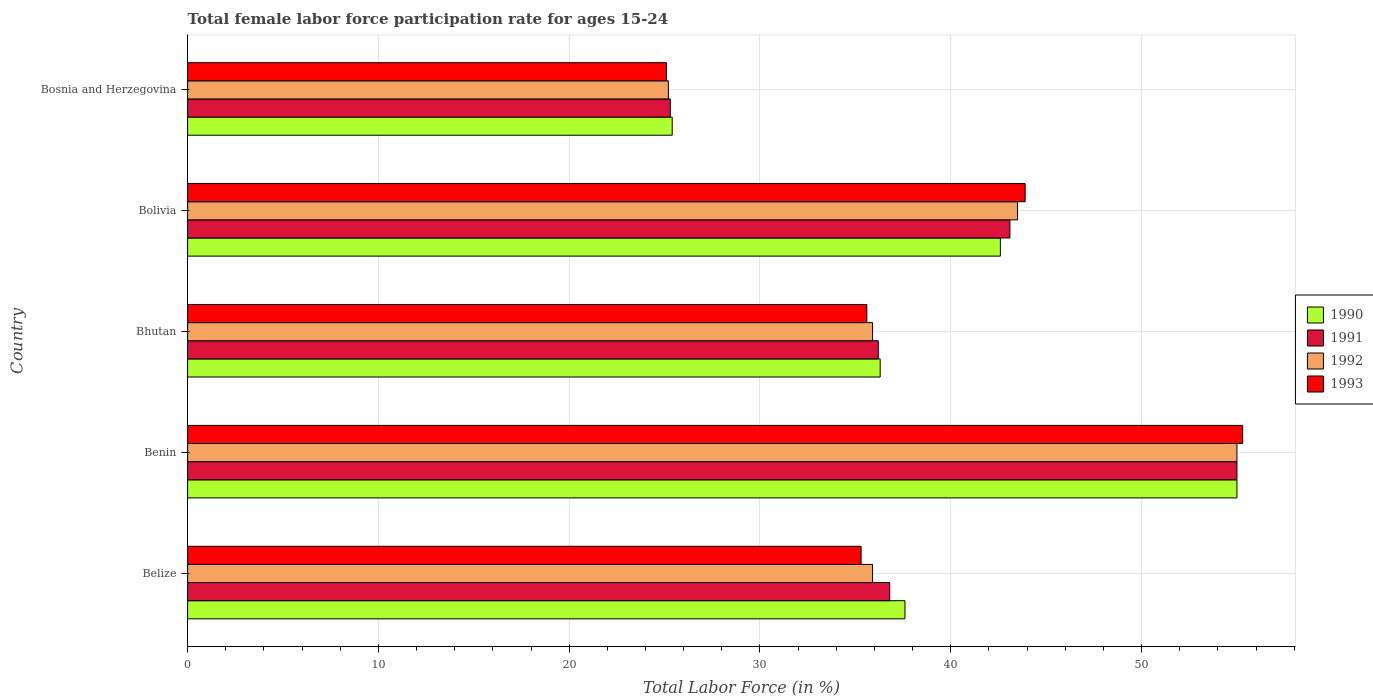How many different coloured bars are there?
Provide a short and direct response. 4. How many groups of bars are there?
Give a very brief answer. 5. Are the number of bars on each tick of the Y-axis equal?
Make the answer very short. Yes. How many bars are there on the 5th tick from the bottom?
Give a very brief answer. 4. What is the label of the 5th group of bars from the top?
Give a very brief answer. Belize. What is the female labor force participation rate in 1991 in Bosnia and Herzegovina?
Provide a short and direct response. 25.3. Across all countries, what is the minimum female labor force participation rate in 1993?
Provide a short and direct response. 25.1. In which country was the female labor force participation rate in 1992 maximum?
Ensure brevity in your answer.  Benin. In which country was the female labor force participation rate in 1992 minimum?
Provide a succinct answer. Bosnia and Herzegovina. What is the total female labor force participation rate in 1993 in the graph?
Keep it short and to the point. 195.2. What is the difference between the female labor force participation rate in 1993 in Bolivia and the female labor force participation rate in 1990 in Benin?
Ensure brevity in your answer.  -11.1. What is the average female labor force participation rate in 1992 per country?
Your answer should be compact. 39.1. What is the difference between the female labor force participation rate in 1990 and female labor force participation rate in 1991 in Belize?
Offer a very short reply. 0.8. In how many countries, is the female labor force participation rate in 1991 greater than 4 %?
Give a very brief answer. 5. What is the ratio of the female labor force participation rate in 1990 in Bhutan to that in Bosnia and Herzegovina?
Ensure brevity in your answer.  1.43. Is the female labor force participation rate in 1991 in Bhutan less than that in Bolivia?
Your answer should be compact. Yes. What is the difference between the highest and the second highest female labor force participation rate in 1991?
Make the answer very short. 11.9. What is the difference between the highest and the lowest female labor force participation rate in 1991?
Your answer should be compact. 29.7. Is it the case that in every country, the sum of the female labor force participation rate in 1991 and female labor force participation rate in 1992 is greater than the sum of female labor force participation rate in 1993 and female labor force participation rate in 1990?
Your answer should be very brief. No. What does the 2nd bar from the top in Belize represents?
Provide a succinct answer. 1992. What does the 2nd bar from the bottom in Benin represents?
Make the answer very short. 1991. Is it the case that in every country, the sum of the female labor force participation rate in 1992 and female labor force participation rate in 1990 is greater than the female labor force participation rate in 1991?
Your answer should be very brief. Yes. How many legend labels are there?
Your answer should be very brief. 4. How are the legend labels stacked?
Your answer should be very brief. Vertical. What is the title of the graph?
Keep it short and to the point. Total female labor force participation rate for ages 15-24. Does "2014" appear as one of the legend labels in the graph?
Provide a succinct answer. No. What is the label or title of the X-axis?
Give a very brief answer. Total Labor Force (in %). What is the label or title of the Y-axis?
Ensure brevity in your answer.  Country. What is the Total Labor Force (in %) in 1990 in Belize?
Give a very brief answer. 37.6. What is the Total Labor Force (in %) of 1991 in Belize?
Your answer should be very brief. 36.8. What is the Total Labor Force (in %) of 1992 in Belize?
Keep it short and to the point. 35.9. What is the Total Labor Force (in %) of 1993 in Belize?
Your response must be concise. 35.3. What is the Total Labor Force (in %) in 1990 in Benin?
Keep it short and to the point. 55. What is the Total Labor Force (in %) of 1993 in Benin?
Provide a short and direct response. 55.3. What is the Total Labor Force (in %) of 1990 in Bhutan?
Your answer should be compact. 36.3. What is the Total Labor Force (in %) of 1991 in Bhutan?
Offer a very short reply. 36.2. What is the Total Labor Force (in %) of 1992 in Bhutan?
Ensure brevity in your answer.  35.9. What is the Total Labor Force (in %) in 1993 in Bhutan?
Provide a short and direct response. 35.6. What is the Total Labor Force (in %) of 1990 in Bolivia?
Give a very brief answer. 42.6. What is the Total Labor Force (in %) of 1991 in Bolivia?
Offer a very short reply. 43.1. What is the Total Labor Force (in %) in 1992 in Bolivia?
Offer a very short reply. 43.5. What is the Total Labor Force (in %) of 1993 in Bolivia?
Your response must be concise. 43.9. What is the Total Labor Force (in %) in 1990 in Bosnia and Herzegovina?
Keep it short and to the point. 25.4. What is the Total Labor Force (in %) in 1991 in Bosnia and Herzegovina?
Offer a terse response. 25.3. What is the Total Labor Force (in %) of 1992 in Bosnia and Herzegovina?
Give a very brief answer. 25.2. What is the Total Labor Force (in %) in 1993 in Bosnia and Herzegovina?
Offer a terse response. 25.1. Across all countries, what is the maximum Total Labor Force (in %) of 1990?
Your answer should be compact. 55. Across all countries, what is the maximum Total Labor Force (in %) in 1992?
Offer a very short reply. 55. Across all countries, what is the maximum Total Labor Force (in %) of 1993?
Keep it short and to the point. 55.3. Across all countries, what is the minimum Total Labor Force (in %) of 1990?
Offer a terse response. 25.4. Across all countries, what is the minimum Total Labor Force (in %) in 1991?
Offer a very short reply. 25.3. Across all countries, what is the minimum Total Labor Force (in %) of 1992?
Provide a succinct answer. 25.2. Across all countries, what is the minimum Total Labor Force (in %) in 1993?
Your response must be concise. 25.1. What is the total Total Labor Force (in %) in 1990 in the graph?
Keep it short and to the point. 196.9. What is the total Total Labor Force (in %) of 1991 in the graph?
Ensure brevity in your answer.  196.4. What is the total Total Labor Force (in %) of 1992 in the graph?
Offer a very short reply. 195.5. What is the total Total Labor Force (in %) in 1993 in the graph?
Your answer should be compact. 195.2. What is the difference between the Total Labor Force (in %) of 1990 in Belize and that in Benin?
Offer a terse response. -17.4. What is the difference between the Total Labor Force (in %) of 1991 in Belize and that in Benin?
Ensure brevity in your answer.  -18.2. What is the difference between the Total Labor Force (in %) of 1992 in Belize and that in Benin?
Your answer should be very brief. -19.1. What is the difference between the Total Labor Force (in %) in 1991 in Belize and that in Bhutan?
Give a very brief answer. 0.6. What is the difference between the Total Labor Force (in %) of 1992 in Belize and that in Bhutan?
Your answer should be very brief. 0. What is the difference between the Total Labor Force (in %) in 1993 in Belize and that in Bolivia?
Offer a terse response. -8.6. What is the difference between the Total Labor Force (in %) of 1990 in Belize and that in Bosnia and Herzegovina?
Make the answer very short. 12.2. What is the difference between the Total Labor Force (in %) in 1991 in Belize and that in Bosnia and Herzegovina?
Make the answer very short. 11.5. What is the difference between the Total Labor Force (in %) of 1992 in Belize and that in Bosnia and Herzegovina?
Keep it short and to the point. 10.7. What is the difference between the Total Labor Force (in %) of 1991 in Benin and that in Bhutan?
Provide a succinct answer. 18.8. What is the difference between the Total Labor Force (in %) of 1993 in Benin and that in Bhutan?
Ensure brevity in your answer.  19.7. What is the difference between the Total Labor Force (in %) in 1990 in Benin and that in Bolivia?
Offer a very short reply. 12.4. What is the difference between the Total Labor Force (in %) of 1993 in Benin and that in Bolivia?
Your response must be concise. 11.4. What is the difference between the Total Labor Force (in %) of 1990 in Benin and that in Bosnia and Herzegovina?
Offer a very short reply. 29.6. What is the difference between the Total Labor Force (in %) of 1991 in Benin and that in Bosnia and Herzegovina?
Keep it short and to the point. 29.7. What is the difference between the Total Labor Force (in %) of 1992 in Benin and that in Bosnia and Herzegovina?
Your answer should be very brief. 29.8. What is the difference between the Total Labor Force (in %) of 1993 in Benin and that in Bosnia and Herzegovina?
Keep it short and to the point. 30.2. What is the difference between the Total Labor Force (in %) in 1992 in Bhutan and that in Bolivia?
Make the answer very short. -7.6. What is the difference between the Total Labor Force (in %) of 1990 in Bhutan and that in Bosnia and Herzegovina?
Offer a very short reply. 10.9. What is the difference between the Total Labor Force (in %) of 1991 in Bhutan and that in Bosnia and Herzegovina?
Your answer should be very brief. 10.9. What is the difference between the Total Labor Force (in %) of 1992 in Bhutan and that in Bosnia and Herzegovina?
Your answer should be compact. 10.7. What is the difference between the Total Labor Force (in %) of 1993 in Bhutan and that in Bosnia and Herzegovina?
Offer a terse response. 10.5. What is the difference between the Total Labor Force (in %) in 1992 in Bolivia and that in Bosnia and Herzegovina?
Offer a very short reply. 18.3. What is the difference between the Total Labor Force (in %) of 1993 in Bolivia and that in Bosnia and Herzegovina?
Provide a short and direct response. 18.8. What is the difference between the Total Labor Force (in %) in 1990 in Belize and the Total Labor Force (in %) in 1991 in Benin?
Offer a terse response. -17.4. What is the difference between the Total Labor Force (in %) in 1990 in Belize and the Total Labor Force (in %) in 1992 in Benin?
Make the answer very short. -17.4. What is the difference between the Total Labor Force (in %) of 1990 in Belize and the Total Labor Force (in %) of 1993 in Benin?
Give a very brief answer. -17.7. What is the difference between the Total Labor Force (in %) in 1991 in Belize and the Total Labor Force (in %) in 1992 in Benin?
Ensure brevity in your answer.  -18.2. What is the difference between the Total Labor Force (in %) of 1991 in Belize and the Total Labor Force (in %) of 1993 in Benin?
Provide a succinct answer. -18.5. What is the difference between the Total Labor Force (in %) of 1992 in Belize and the Total Labor Force (in %) of 1993 in Benin?
Provide a short and direct response. -19.4. What is the difference between the Total Labor Force (in %) of 1990 in Belize and the Total Labor Force (in %) of 1992 in Bhutan?
Your answer should be compact. 1.7. What is the difference between the Total Labor Force (in %) of 1990 in Belize and the Total Labor Force (in %) of 1993 in Bhutan?
Your answer should be compact. 2. What is the difference between the Total Labor Force (in %) in 1990 in Belize and the Total Labor Force (in %) in 1992 in Bolivia?
Your answer should be very brief. -5.9. What is the difference between the Total Labor Force (in %) in 1990 in Belize and the Total Labor Force (in %) in 1991 in Bosnia and Herzegovina?
Offer a very short reply. 12.3. What is the difference between the Total Labor Force (in %) in 1990 in Belize and the Total Labor Force (in %) in 1993 in Bosnia and Herzegovina?
Keep it short and to the point. 12.5. What is the difference between the Total Labor Force (in %) in 1991 in Belize and the Total Labor Force (in %) in 1992 in Bosnia and Herzegovina?
Your answer should be compact. 11.6. What is the difference between the Total Labor Force (in %) in 1991 in Belize and the Total Labor Force (in %) in 1993 in Bosnia and Herzegovina?
Provide a succinct answer. 11.7. What is the difference between the Total Labor Force (in %) of 1992 in Belize and the Total Labor Force (in %) of 1993 in Bosnia and Herzegovina?
Give a very brief answer. 10.8. What is the difference between the Total Labor Force (in %) in 1990 in Benin and the Total Labor Force (in %) in 1991 in Bhutan?
Ensure brevity in your answer.  18.8. What is the difference between the Total Labor Force (in %) of 1990 in Benin and the Total Labor Force (in %) of 1993 in Bhutan?
Keep it short and to the point. 19.4. What is the difference between the Total Labor Force (in %) in 1991 in Benin and the Total Labor Force (in %) in 1993 in Bhutan?
Give a very brief answer. 19.4. What is the difference between the Total Labor Force (in %) in 1992 in Benin and the Total Labor Force (in %) in 1993 in Bhutan?
Offer a terse response. 19.4. What is the difference between the Total Labor Force (in %) of 1990 in Benin and the Total Labor Force (in %) of 1991 in Bolivia?
Give a very brief answer. 11.9. What is the difference between the Total Labor Force (in %) in 1990 in Benin and the Total Labor Force (in %) in 1992 in Bolivia?
Give a very brief answer. 11.5. What is the difference between the Total Labor Force (in %) of 1990 in Benin and the Total Labor Force (in %) of 1993 in Bolivia?
Offer a very short reply. 11.1. What is the difference between the Total Labor Force (in %) in 1991 in Benin and the Total Labor Force (in %) in 1993 in Bolivia?
Keep it short and to the point. 11.1. What is the difference between the Total Labor Force (in %) in 1992 in Benin and the Total Labor Force (in %) in 1993 in Bolivia?
Your answer should be very brief. 11.1. What is the difference between the Total Labor Force (in %) in 1990 in Benin and the Total Labor Force (in %) in 1991 in Bosnia and Herzegovina?
Your answer should be compact. 29.7. What is the difference between the Total Labor Force (in %) of 1990 in Benin and the Total Labor Force (in %) of 1992 in Bosnia and Herzegovina?
Make the answer very short. 29.8. What is the difference between the Total Labor Force (in %) of 1990 in Benin and the Total Labor Force (in %) of 1993 in Bosnia and Herzegovina?
Provide a short and direct response. 29.9. What is the difference between the Total Labor Force (in %) in 1991 in Benin and the Total Labor Force (in %) in 1992 in Bosnia and Herzegovina?
Your response must be concise. 29.8. What is the difference between the Total Labor Force (in %) in 1991 in Benin and the Total Labor Force (in %) in 1993 in Bosnia and Herzegovina?
Your answer should be very brief. 29.9. What is the difference between the Total Labor Force (in %) in 1992 in Benin and the Total Labor Force (in %) in 1993 in Bosnia and Herzegovina?
Your answer should be very brief. 29.9. What is the difference between the Total Labor Force (in %) in 1990 in Bhutan and the Total Labor Force (in %) in 1991 in Bolivia?
Your answer should be compact. -6.8. What is the difference between the Total Labor Force (in %) of 1991 in Bhutan and the Total Labor Force (in %) of 1993 in Bolivia?
Ensure brevity in your answer.  -7.7. What is the difference between the Total Labor Force (in %) in 1992 in Bhutan and the Total Labor Force (in %) in 1993 in Bolivia?
Make the answer very short. -8. What is the difference between the Total Labor Force (in %) of 1990 in Bhutan and the Total Labor Force (in %) of 1992 in Bosnia and Herzegovina?
Offer a very short reply. 11.1. What is the difference between the Total Labor Force (in %) of 1990 in Bhutan and the Total Labor Force (in %) of 1993 in Bosnia and Herzegovina?
Provide a short and direct response. 11.2. What is the difference between the Total Labor Force (in %) in 1991 in Bhutan and the Total Labor Force (in %) in 1992 in Bosnia and Herzegovina?
Keep it short and to the point. 11. What is the difference between the Total Labor Force (in %) in 1992 in Bhutan and the Total Labor Force (in %) in 1993 in Bosnia and Herzegovina?
Offer a very short reply. 10.8. What is the difference between the Total Labor Force (in %) in 1990 in Bolivia and the Total Labor Force (in %) in 1991 in Bosnia and Herzegovina?
Give a very brief answer. 17.3. What is the difference between the Total Labor Force (in %) of 1990 in Bolivia and the Total Labor Force (in %) of 1993 in Bosnia and Herzegovina?
Keep it short and to the point. 17.5. What is the difference between the Total Labor Force (in %) in 1991 in Bolivia and the Total Labor Force (in %) in 1992 in Bosnia and Herzegovina?
Your response must be concise. 17.9. What is the average Total Labor Force (in %) of 1990 per country?
Give a very brief answer. 39.38. What is the average Total Labor Force (in %) in 1991 per country?
Offer a terse response. 39.28. What is the average Total Labor Force (in %) in 1992 per country?
Your answer should be compact. 39.1. What is the average Total Labor Force (in %) of 1993 per country?
Provide a short and direct response. 39.04. What is the difference between the Total Labor Force (in %) in 1990 and Total Labor Force (in %) in 1991 in Belize?
Offer a terse response. 0.8. What is the difference between the Total Labor Force (in %) in 1990 and Total Labor Force (in %) in 1992 in Belize?
Your response must be concise. 1.7. What is the difference between the Total Labor Force (in %) in 1990 and Total Labor Force (in %) in 1993 in Belize?
Ensure brevity in your answer.  2.3. What is the difference between the Total Labor Force (in %) of 1991 and Total Labor Force (in %) of 1993 in Belize?
Provide a short and direct response. 1.5. What is the difference between the Total Labor Force (in %) in 1992 and Total Labor Force (in %) in 1993 in Belize?
Offer a very short reply. 0.6. What is the difference between the Total Labor Force (in %) of 1990 and Total Labor Force (in %) of 1991 in Benin?
Make the answer very short. 0. What is the difference between the Total Labor Force (in %) in 1990 and Total Labor Force (in %) in 1992 in Benin?
Provide a succinct answer. 0. What is the difference between the Total Labor Force (in %) in 1990 and Total Labor Force (in %) in 1992 in Bhutan?
Your response must be concise. 0.4. What is the difference between the Total Labor Force (in %) in 1990 and Total Labor Force (in %) in 1993 in Bhutan?
Keep it short and to the point. 0.7. What is the difference between the Total Labor Force (in %) of 1991 and Total Labor Force (in %) of 1992 in Bhutan?
Ensure brevity in your answer.  0.3. What is the difference between the Total Labor Force (in %) of 1990 and Total Labor Force (in %) of 1991 in Bolivia?
Your answer should be compact. -0.5. What is the difference between the Total Labor Force (in %) in 1991 and Total Labor Force (in %) in 1992 in Bolivia?
Offer a very short reply. -0.4. What is the difference between the Total Labor Force (in %) of 1990 and Total Labor Force (in %) of 1991 in Bosnia and Herzegovina?
Offer a terse response. 0.1. What is the difference between the Total Labor Force (in %) of 1990 and Total Labor Force (in %) of 1993 in Bosnia and Herzegovina?
Offer a very short reply. 0.3. What is the difference between the Total Labor Force (in %) in 1991 and Total Labor Force (in %) in 1993 in Bosnia and Herzegovina?
Make the answer very short. 0.2. What is the ratio of the Total Labor Force (in %) of 1990 in Belize to that in Benin?
Provide a short and direct response. 0.68. What is the ratio of the Total Labor Force (in %) of 1991 in Belize to that in Benin?
Your answer should be very brief. 0.67. What is the ratio of the Total Labor Force (in %) of 1992 in Belize to that in Benin?
Your response must be concise. 0.65. What is the ratio of the Total Labor Force (in %) of 1993 in Belize to that in Benin?
Offer a very short reply. 0.64. What is the ratio of the Total Labor Force (in %) of 1990 in Belize to that in Bhutan?
Your answer should be very brief. 1.04. What is the ratio of the Total Labor Force (in %) in 1991 in Belize to that in Bhutan?
Ensure brevity in your answer.  1.02. What is the ratio of the Total Labor Force (in %) in 1992 in Belize to that in Bhutan?
Offer a very short reply. 1. What is the ratio of the Total Labor Force (in %) in 1990 in Belize to that in Bolivia?
Your answer should be very brief. 0.88. What is the ratio of the Total Labor Force (in %) of 1991 in Belize to that in Bolivia?
Offer a very short reply. 0.85. What is the ratio of the Total Labor Force (in %) of 1992 in Belize to that in Bolivia?
Make the answer very short. 0.83. What is the ratio of the Total Labor Force (in %) in 1993 in Belize to that in Bolivia?
Give a very brief answer. 0.8. What is the ratio of the Total Labor Force (in %) of 1990 in Belize to that in Bosnia and Herzegovina?
Your answer should be very brief. 1.48. What is the ratio of the Total Labor Force (in %) of 1991 in Belize to that in Bosnia and Herzegovina?
Keep it short and to the point. 1.45. What is the ratio of the Total Labor Force (in %) in 1992 in Belize to that in Bosnia and Herzegovina?
Keep it short and to the point. 1.42. What is the ratio of the Total Labor Force (in %) in 1993 in Belize to that in Bosnia and Herzegovina?
Provide a short and direct response. 1.41. What is the ratio of the Total Labor Force (in %) in 1990 in Benin to that in Bhutan?
Keep it short and to the point. 1.52. What is the ratio of the Total Labor Force (in %) of 1991 in Benin to that in Bhutan?
Offer a terse response. 1.52. What is the ratio of the Total Labor Force (in %) in 1992 in Benin to that in Bhutan?
Your response must be concise. 1.53. What is the ratio of the Total Labor Force (in %) of 1993 in Benin to that in Bhutan?
Provide a succinct answer. 1.55. What is the ratio of the Total Labor Force (in %) in 1990 in Benin to that in Bolivia?
Make the answer very short. 1.29. What is the ratio of the Total Labor Force (in %) of 1991 in Benin to that in Bolivia?
Keep it short and to the point. 1.28. What is the ratio of the Total Labor Force (in %) of 1992 in Benin to that in Bolivia?
Offer a terse response. 1.26. What is the ratio of the Total Labor Force (in %) in 1993 in Benin to that in Bolivia?
Provide a short and direct response. 1.26. What is the ratio of the Total Labor Force (in %) in 1990 in Benin to that in Bosnia and Herzegovina?
Your response must be concise. 2.17. What is the ratio of the Total Labor Force (in %) of 1991 in Benin to that in Bosnia and Herzegovina?
Provide a short and direct response. 2.17. What is the ratio of the Total Labor Force (in %) of 1992 in Benin to that in Bosnia and Herzegovina?
Provide a short and direct response. 2.18. What is the ratio of the Total Labor Force (in %) in 1993 in Benin to that in Bosnia and Herzegovina?
Your answer should be compact. 2.2. What is the ratio of the Total Labor Force (in %) in 1990 in Bhutan to that in Bolivia?
Give a very brief answer. 0.85. What is the ratio of the Total Labor Force (in %) in 1991 in Bhutan to that in Bolivia?
Ensure brevity in your answer.  0.84. What is the ratio of the Total Labor Force (in %) of 1992 in Bhutan to that in Bolivia?
Your answer should be compact. 0.83. What is the ratio of the Total Labor Force (in %) of 1993 in Bhutan to that in Bolivia?
Your answer should be compact. 0.81. What is the ratio of the Total Labor Force (in %) in 1990 in Bhutan to that in Bosnia and Herzegovina?
Keep it short and to the point. 1.43. What is the ratio of the Total Labor Force (in %) in 1991 in Bhutan to that in Bosnia and Herzegovina?
Offer a terse response. 1.43. What is the ratio of the Total Labor Force (in %) of 1992 in Bhutan to that in Bosnia and Herzegovina?
Your answer should be compact. 1.42. What is the ratio of the Total Labor Force (in %) in 1993 in Bhutan to that in Bosnia and Herzegovina?
Offer a terse response. 1.42. What is the ratio of the Total Labor Force (in %) of 1990 in Bolivia to that in Bosnia and Herzegovina?
Keep it short and to the point. 1.68. What is the ratio of the Total Labor Force (in %) of 1991 in Bolivia to that in Bosnia and Herzegovina?
Keep it short and to the point. 1.7. What is the ratio of the Total Labor Force (in %) in 1992 in Bolivia to that in Bosnia and Herzegovina?
Provide a succinct answer. 1.73. What is the ratio of the Total Labor Force (in %) in 1993 in Bolivia to that in Bosnia and Herzegovina?
Your response must be concise. 1.75. What is the difference between the highest and the second highest Total Labor Force (in %) in 1992?
Give a very brief answer. 11.5. What is the difference between the highest and the lowest Total Labor Force (in %) of 1990?
Provide a short and direct response. 29.6. What is the difference between the highest and the lowest Total Labor Force (in %) of 1991?
Offer a very short reply. 29.7. What is the difference between the highest and the lowest Total Labor Force (in %) of 1992?
Provide a succinct answer. 29.8. What is the difference between the highest and the lowest Total Labor Force (in %) of 1993?
Keep it short and to the point. 30.2. 